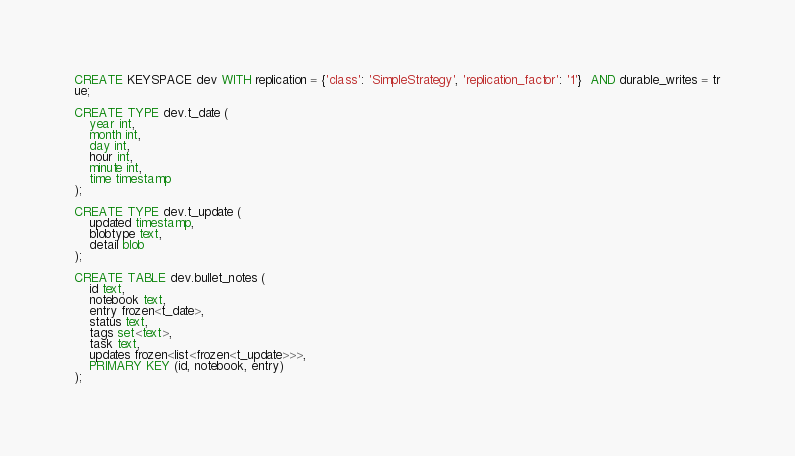<code> <loc_0><loc_0><loc_500><loc_500><_SQL_>CREATE KEYSPACE dev WITH replication = {'class': 'SimpleStrategy', 'replication_factor': '1'}  AND durable_writes = tr
ue;

CREATE TYPE dev.t_date (
    year int,
    month int,
    day int,
    hour int,
    minute int,
    time timestamp
);

CREATE TYPE dev.t_update (
    updated timestamp,
    blobtype text,
    detail blob
);

CREATE TABLE dev.bullet_notes (
    id text,
    notebook text,
    entry frozen<t_date>,
    status text,
    tags set<text>,
    task text,
    updates frozen<list<frozen<t_update>>>,
    PRIMARY KEY (id, notebook, entry)
);</code> 